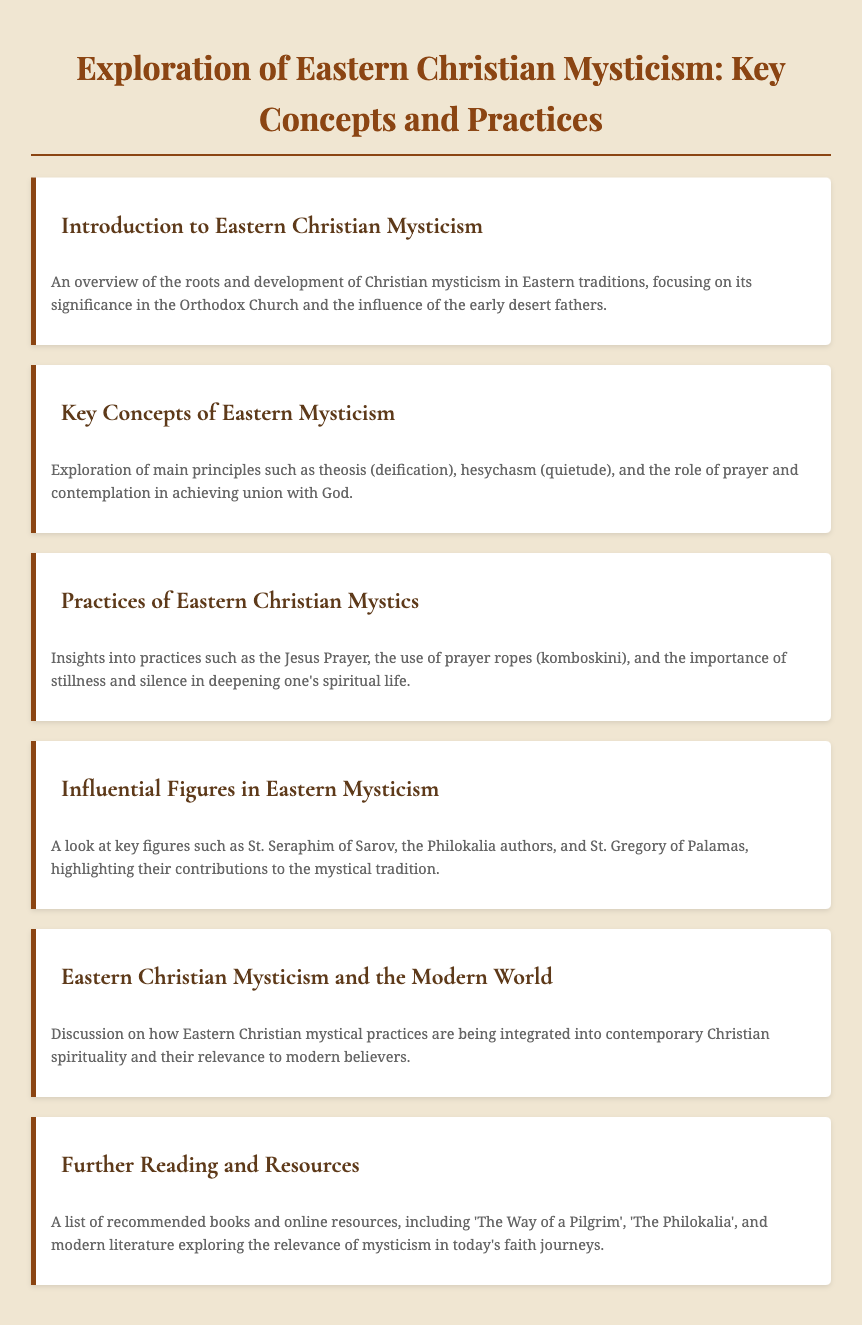what is the title of the document? The title is explicitly given at the top of the document.
Answer: Exploration of Eastern Christian Mysticism: Key Concepts and Practices what practice is associated with the Eastern Christian Mystics? The document highlights specific practices that they engage in as part of their spiritual life.
Answer: Jesus Prayer who wrote 'The Philokalia'? The document refers to the authors of 'The Philokalia' as influential figures in Eastern Mysticism but does not specify individual authors.
Answer: Philokalia authors what is the main theme of the section on key concepts? The section focuses on overarching principles fundamental to Eastern Christian Mysticism.
Answer: Theosis which influential figure is mentioned in the document? The document lists significant figures who contributed to the mystical traditions in Eastern Christianity.
Answer: St. Seraphim of Sarov what does the term hesychasm refer to? The document encompasses various key concepts, including this term, within Eastern Christian practices.
Answer: Quietude how are Eastern Christian mysticism practices perceived in the modern world? The document discusses the relevance of these practices in contemporary spirituality.
Answer: Integrated what type of resources is provided at the end of the document? The last menu item suggests materials for further exploration of the topic.
Answer: Recommended books and online resources 